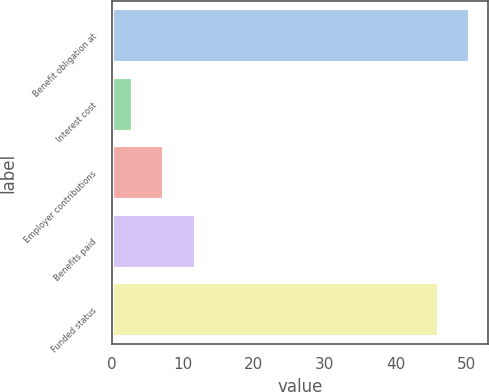<chart> <loc_0><loc_0><loc_500><loc_500><bar_chart><fcel>Benefit obligation at<fcel>Interest cost<fcel>Employer contributions<fcel>Benefits paid<fcel>Funded status<nl><fcel>50.4<fcel>3<fcel>7.4<fcel>11.8<fcel>46<nl></chart> 